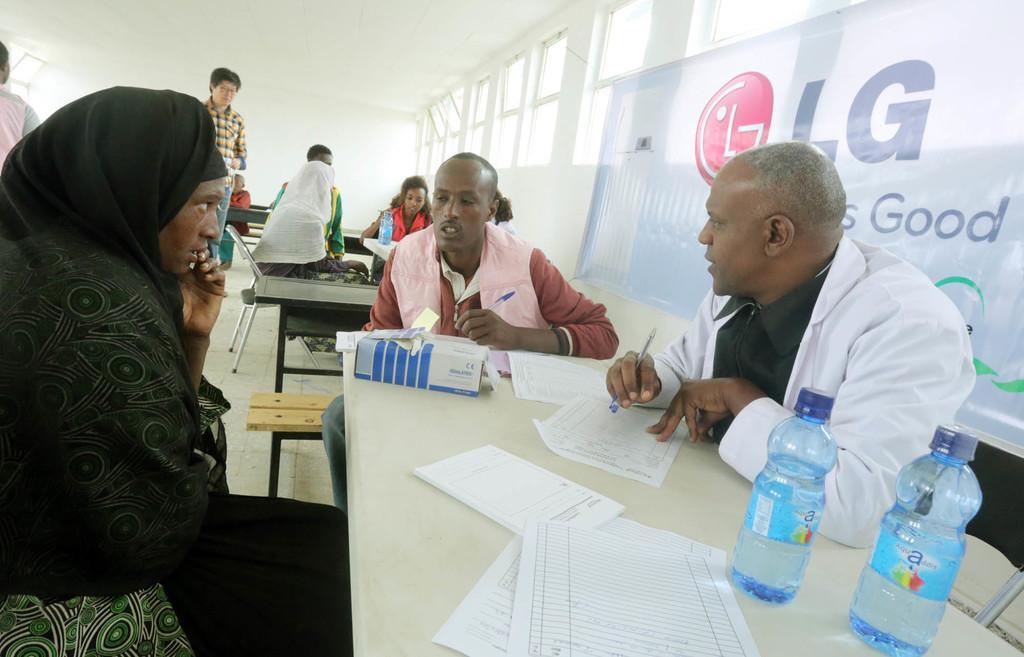How would you summarize this image in a sentence or two? In this image I can see number of people where few are standing and rest all are sitting on chairs. I can also see few tables and on these tables I can see few bottles, few papers, a box and here I can see he is holding a pen. In the background I can see a white colour banner and on it I can see something is written. 